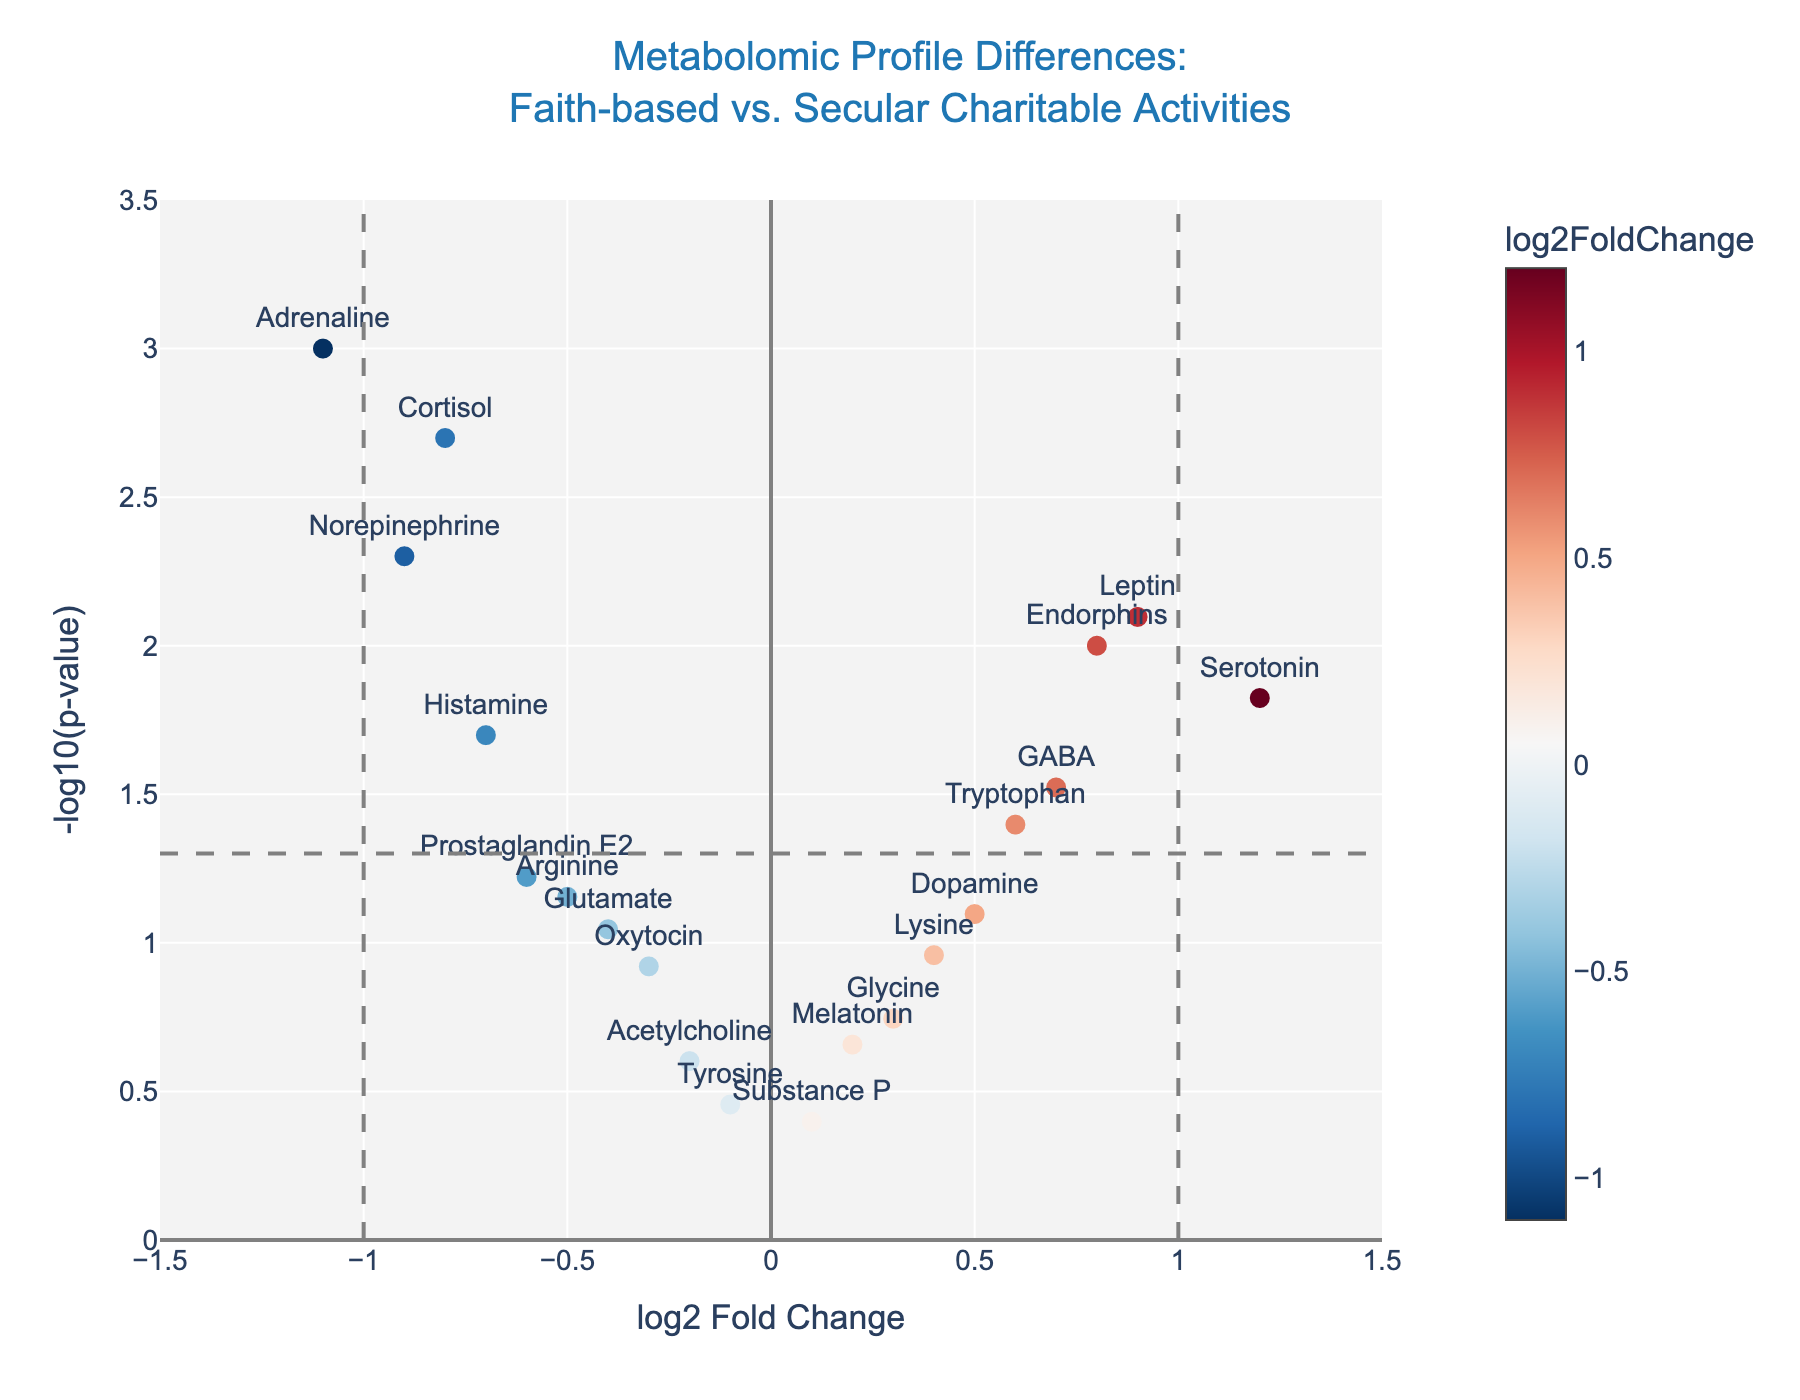What is the title of the plot? The title of the plot is displayed at the top and reads: "Metabolomic Profile Differences: Faith-based vs. Secular Charitable Activities".
Answer: Metabolomic Profile Differences: Faith-based vs. Secular Charitable Activities How many metabolites have a p-value below 0.05? To find the number of metabolites with a p-value below 0.05, count the data points that are above the horizontal line at y = 1.301 (-log10(0.05)).
Answer: 9 Which metabolite has the highest -log10(p-value)? Locate the metabolite with the highest point on the y-axis. The corresponding label is "Adrenaline" at around 3.
Answer: Adrenaline Which metabolite has the largest positive log2FoldChange? Look for the data point furthest to the right on the x-axis; the corresponding metabolite is "Serotonin" at about 1.2.
Answer: Serotonin Do any metabolites have both a log2FoldChange greater than 1 and a p-value below 0.05? Check if any points fall to the right of 1 on the x-axis and above 1.301 on the y-axis. Only "Serotonin" and "Leptin" meet this criterion.
Answer: Yes Which metabolite has the lowest log2FoldChange among those with a significant p-value? Identify significant metabolites (above the horizontal line) and find the one furthest to the left on the x-axis. "Adrenaline" is at approximately -1.1.
Answer: Adrenaline Is there a metabolite with a log2FoldChange less than -0.5 but not significant? Look for points to the left of -0.5 (x-axis) that fall below the horizontal line (y < 1.301). "Arginine" and "Prostaglandin E2" fit this criterion.
Answer: Yes How many metabolites are within the range of -0.5 to 0.5 log2FoldChange? Count the points between -0.5 and 0.5 on the x-axis.
Answer: 8 Which of the metabolites with significant p-values have positive log2FoldChange values? Identify those above the horizontal line and to the right of 0. "Serotonin", "GABA", "Tryptophan", "Endorphins", and "Leptin" meet this criterion.
Answer: 5 What is the log2FoldChange for Dopamine? Locate the point labeled "Dopamine" and note the x-coordinate. The log2FoldChange for Dopamine is approximately 0.5.
Answer: 0.5 